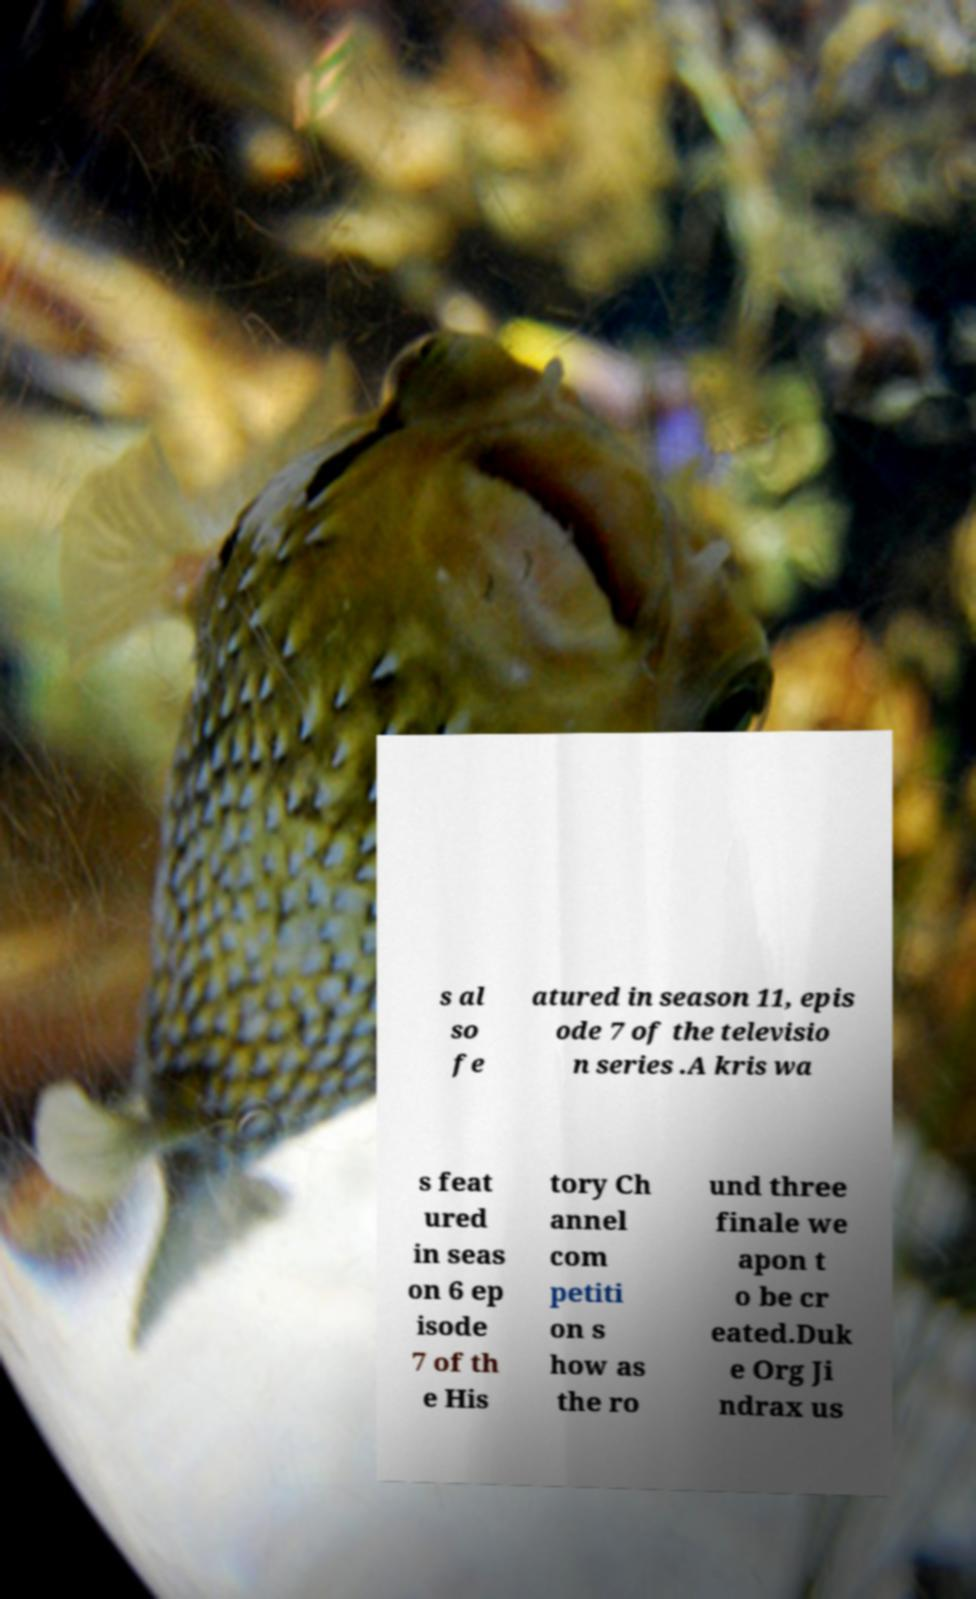I need the written content from this picture converted into text. Can you do that? s al so fe atured in season 11, epis ode 7 of the televisio n series .A kris wa s feat ured in seas on 6 ep isode 7 of th e His tory Ch annel com petiti on s how as the ro und three finale we apon t o be cr eated.Duk e Org Ji ndrax us 